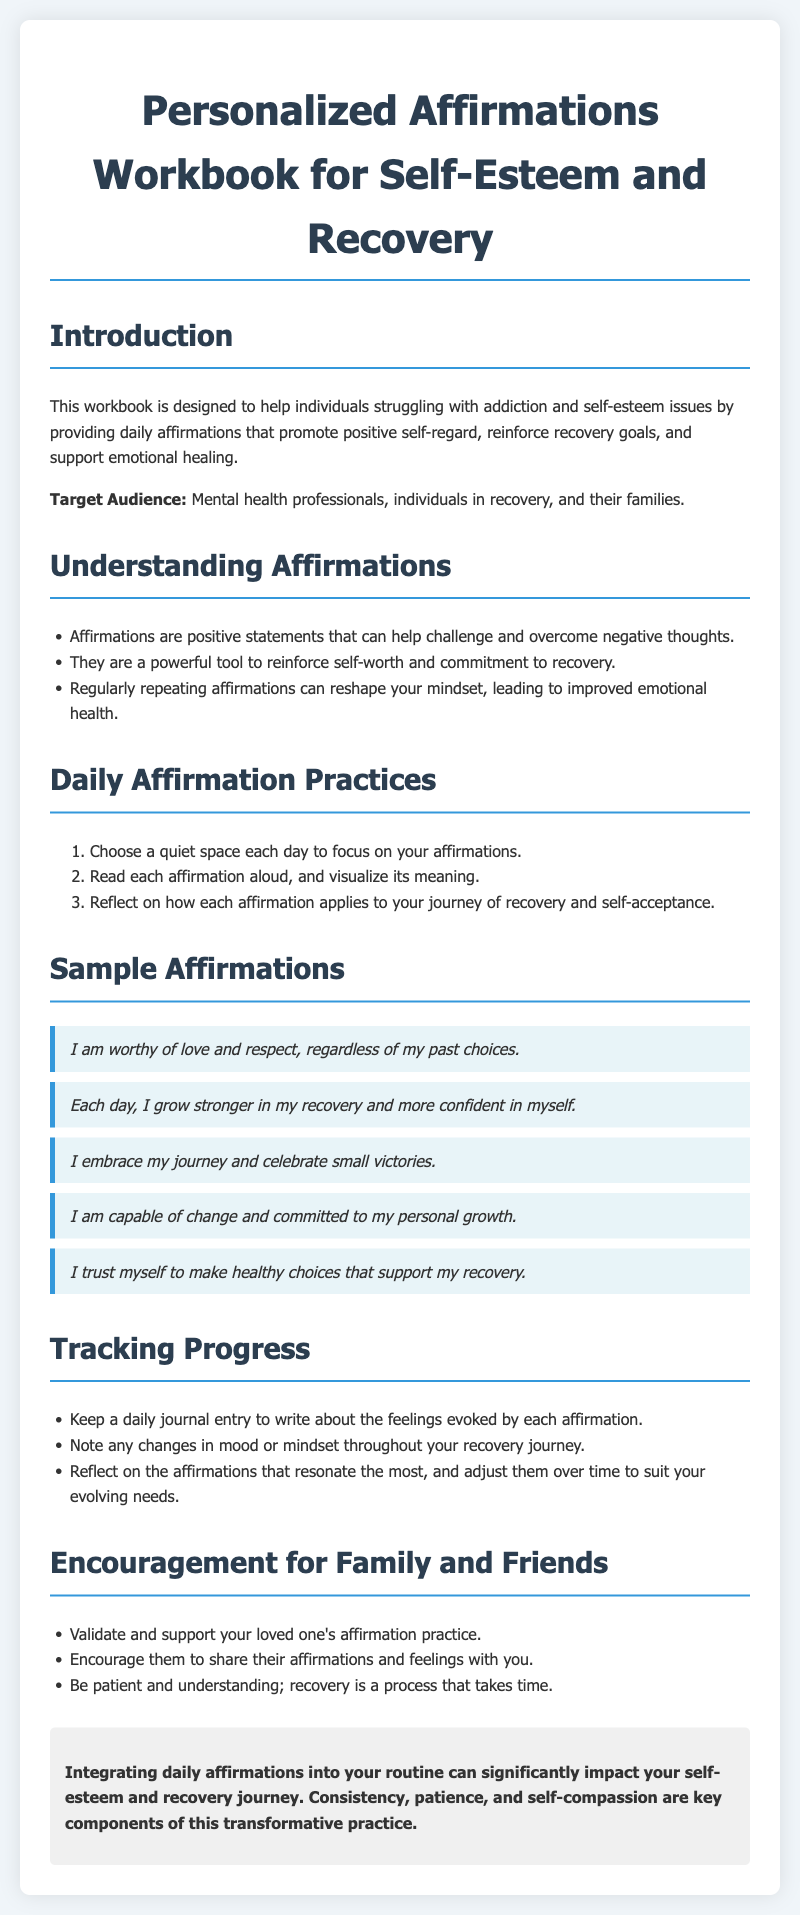What is the purpose of this workbook? The workbook is designed to help individuals struggling with addiction and self-esteem issues by providing daily affirmations that promote positive self-regard, reinforce recovery goals, and support emotional healing.
Answer: To help individuals with addiction and self-esteem issues Who is the target audience? The target audience includes mental health professionals, individuals in recovery, and their families.
Answer: Mental health professionals, individuals in recovery, and their families How many sample affirmations are provided? The document lists five specific example affirmations that individuals can use in their practice.
Answer: Five What should you do after reading each affirmation? You should reflect on how each affirmation applies to your journey of recovery and self-acceptance.
Answer: Reflect on its application to your recovery journey What is suggested to track progress? Keeping a daily journal entry to write about the feelings evoked by each affirmation is suggested to track progress.
Answer: Daily journal entry 